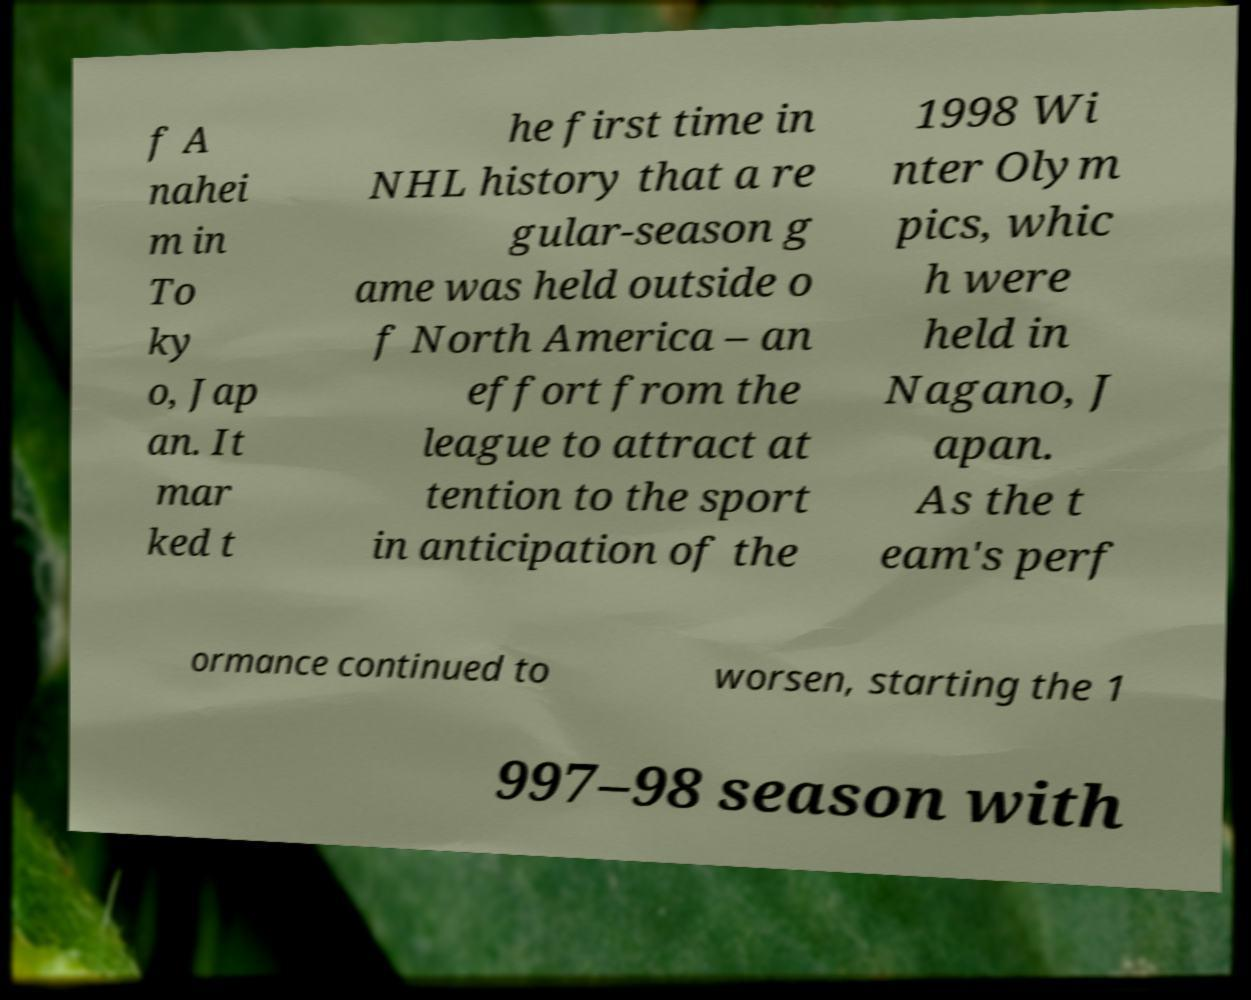What messages or text are displayed in this image? I need them in a readable, typed format. f A nahei m in To ky o, Jap an. It mar ked t he first time in NHL history that a re gular-season g ame was held outside o f North America – an effort from the league to attract at tention to the sport in anticipation of the 1998 Wi nter Olym pics, whic h were held in Nagano, J apan. As the t eam's perf ormance continued to worsen, starting the 1 997–98 season with 